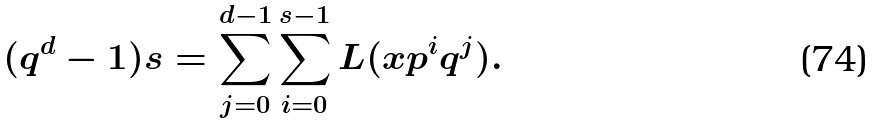<formula> <loc_0><loc_0><loc_500><loc_500>( q ^ { d } - 1 ) s = \sum _ { j = 0 } ^ { d - 1 } \sum _ { i = 0 } ^ { s - 1 } L ( x p ^ { i } q ^ { j } ) .</formula> 